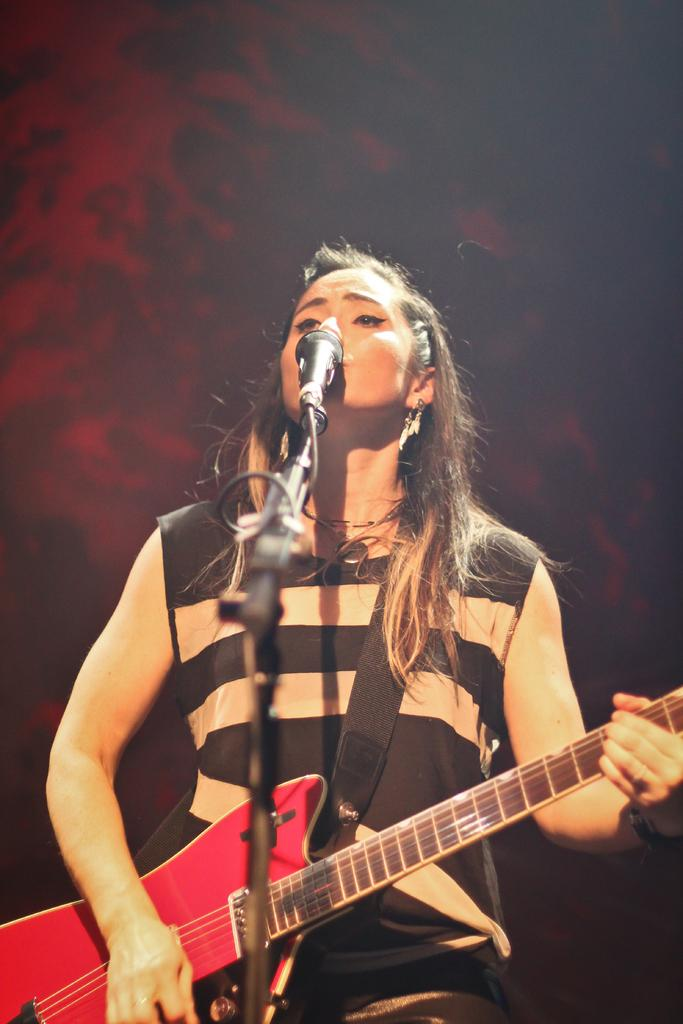What is the woman in the image doing? The woman is playing a guitar and singing. What instrument is the woman playing in the image? The woman is playing a guitar. Can you describe the woman's appearance in the image? The woman has short hair. What type of stocking is the woman wearing in the image? There is no mention of stockings in the image, so it cannot be determined if the woman is wearing any. 